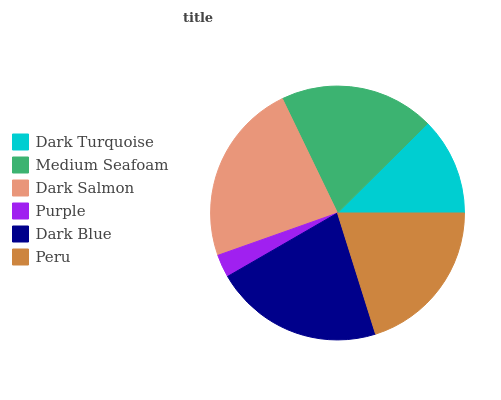Is Purple the minimum?
Answer yes or no. Yes. Is Dark Salmon the maximum?
Answer yes or no. Yes. Is Medium Seafoam the minimum?
Answer yes or no. No. Is Medium Seafoam the maximum?
Answer yes or no. No. Is Medium Seafoam greater than Dark Turquoise?
Answer yes or no. Yes. Is Dark Turquoise less than Medium Seafoam?
Answer yes or no. Yes. Is Dark Turquoise greater than Medium Seafoam?
Answer yes or no. No. Is Medium Seafoam less than Dark Turquoise?
Answer yes or no. No. Is Peru the high median?
Answer yes or no. Yes. Is Medium Seafoam the low median?
Answer yes or no. Yes. Is Medium Seafoam the high median?
Answer yes or no. No. Is Dark Salmon the low median?
Answer yes or no. No. 